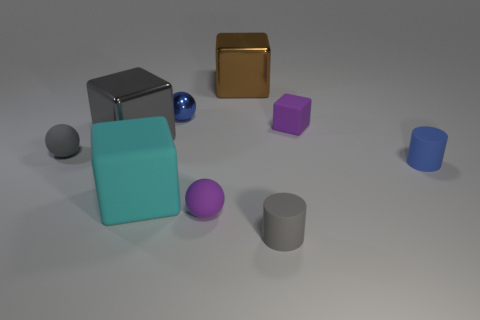There is a small blue thing that is in front of the small purple block; is it the same shape as the blue object left of the brown block?
Keep it short and to the point. No. Is there anything else that has the same material as the big cyan cube?
Provide a short and direct response. Yes. What is the material of the big cyan cube?
Provide a succinct answer. Rubber. What is the cylinder that is in front of the small purple ball made of?
Your answer should be very brief. Rubber. Are there any other things that are the same color as the big rubber thing?
Ensure brevity in your answer.  No. There is a gray cube that is made of the same material as the brown block; what size is it?
Make the answer very short. Large. How many small objects are blue metal spheres or blue cylinders?
Provide a short and direct response. 2. There is a shiny block on the left side of the small matte ball that is to the right of the small object that is on the left side of the blue metal thing; how big is it?
Make the answer very short. Large. What number of other cubes are the same size as the cyan rubber cube?
Your answer should be compact. 2. How many objects are gray cylinders or things behind the tiny blue metallic object?
Offer a very short reply. 2. 